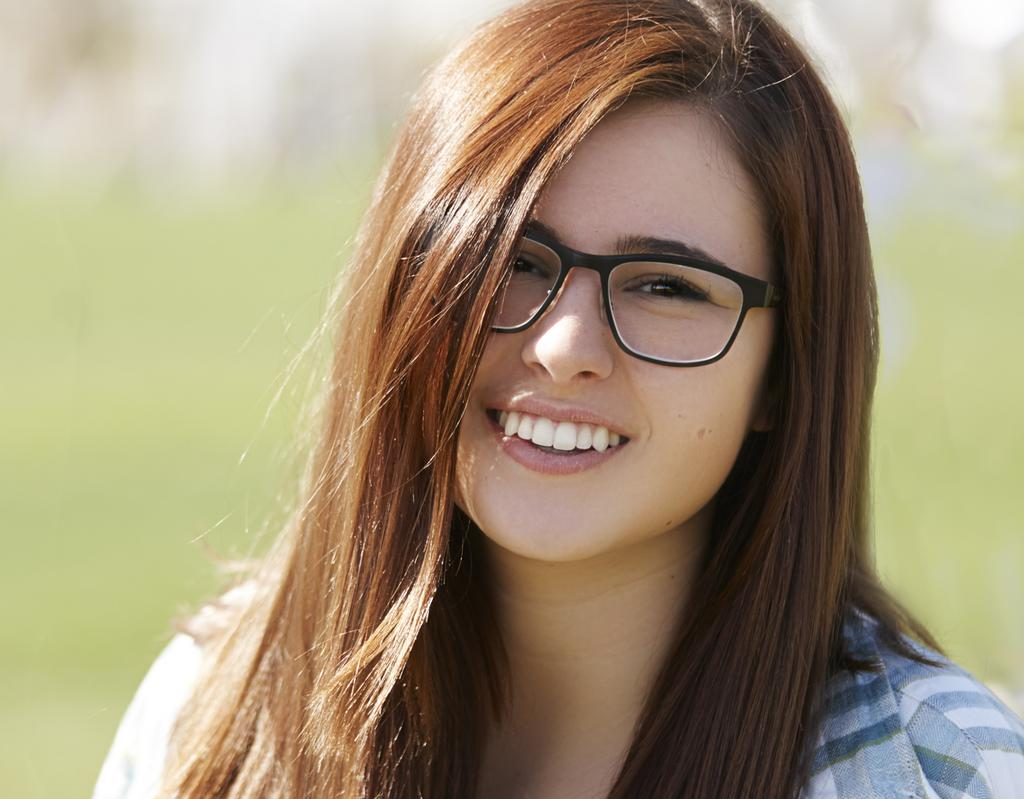Who is the main subject in the image? There is a lady in the center of the image. What is the lady doing in the image? The lady is smiling. What accessory is the lady wearing in the image? The lady is wearing glasses. What is the volume of the lady's voice in the image? The volume of the lady's voice cannot be determined from the image, as it is a still photograph. 